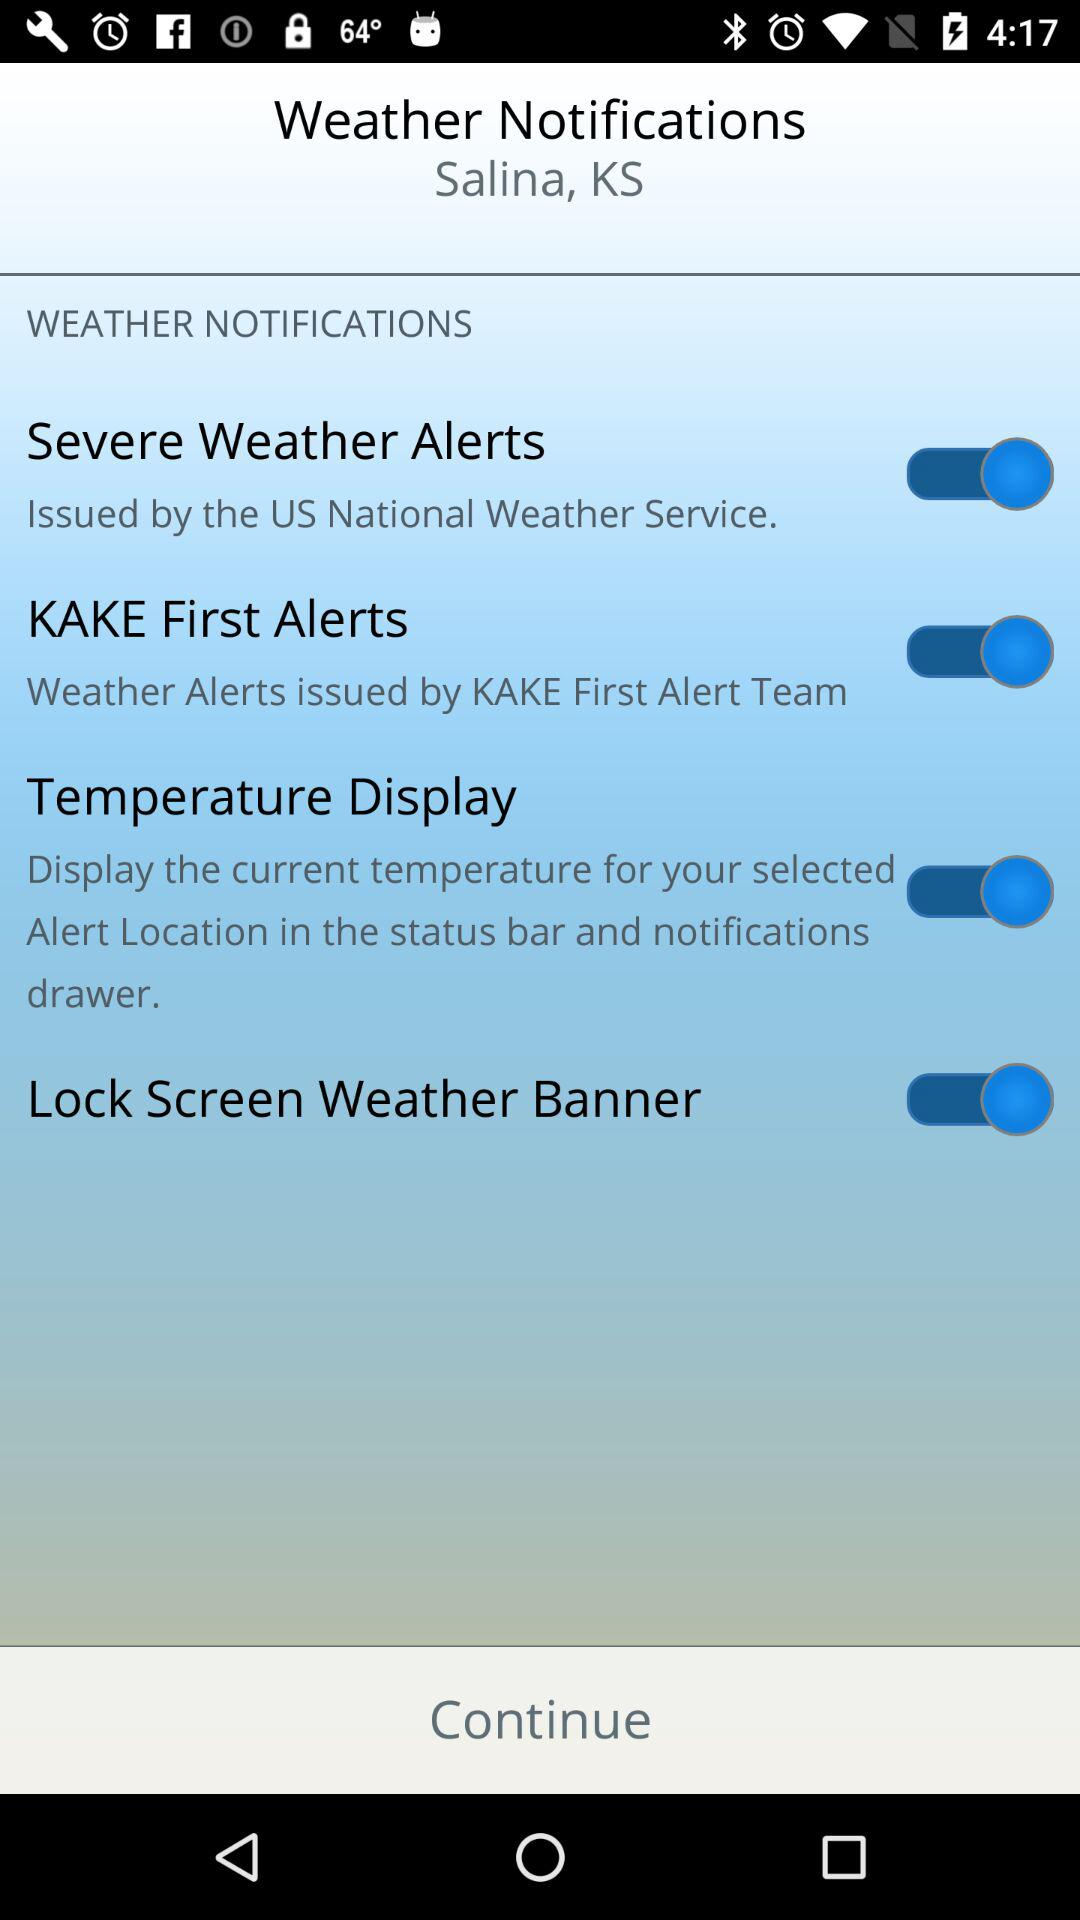What is the status of "Lock Screen Weather Banner"? The status is "on". 